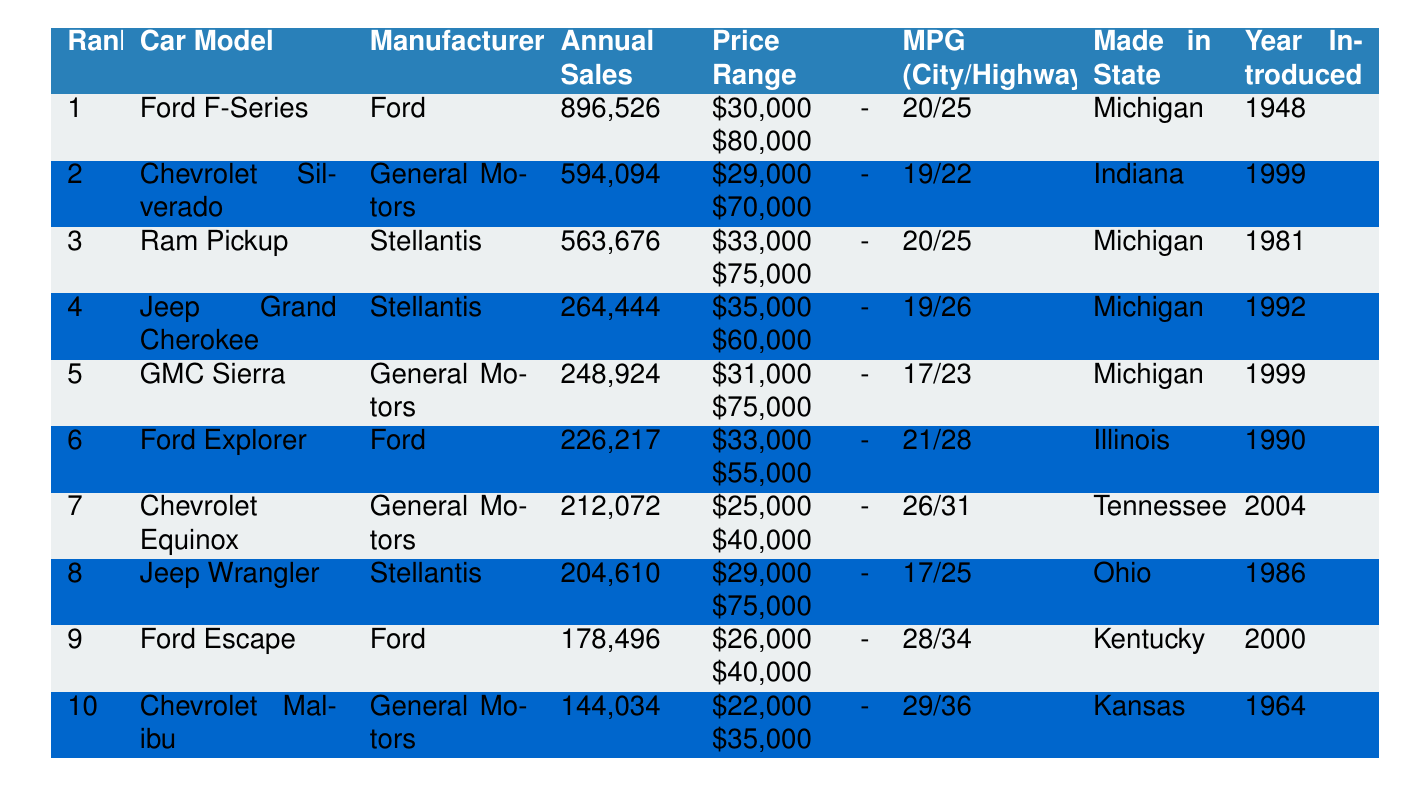What is the car model with the highest annual sales? Referring to the table, the car model listed at rank 1 is the Ford F-Series, which has the highest annual sales figure of 896,526.
Answer: Ford F-Series Which manufacturer produces the Jeep Wrangler? The table shows that the Jeep Wrangler is manufactured by Stellantis, as indicated in the "Manufacturer" column next to its name.
Answer: Stellantis What is the price range of the Chevrolet Silverado? By looking at the table, the price range for the Chevrolet Silverado is listed as $29,000 - $70,000.
Answer: $29,000 - $70,000 How many more annual sales does the Ford Explorer have than the Chevrolet Equinox? The annual sales for the Ford Explorer is 226,217, and for the Chevrolet Equinox, it is 212,072. The difference is 226,217 - 212,072 = 14,145.
Answer: 14,145 Which car model was introduced first, the Ford F-Series or the Chevrolet Malibu? The Ford F-Series was introduced in 1948 and the Chevrolet Malibu in 1964. Since 1948 is earlier than 1964, the Ford F-Series was introduced first.
Answer: Ford F-Series What are the MPG ratings for the Jeep Grand Cherokee? The table states that the Jeep Grand Cherokee has an MPG rating of 19 for city driving and 26 for highway driving.
Answer: 19/26 Which state produces the most car models listed in the top 10? By examining the "Made in State" column, we see Michigan produces 4 cars (Ford F-Series, Ram Pickup, Jeep Grand Cherokee, GMC Sierra), while other states produce fewer, indicating Michigan has the most.
Answer: Michigan What is the average annual sales for the top three car models? The annual sales for the top three models are 896,526 (Ford F-Series), 594,094 (Chevrolet Silverado), and 563,676 (Ram Pickup). The total sales is 896,526 + 594,094 + 563,676 = 2,054,296, and the average is 2,054,296 / 3 = 684,765.33.
Answer: 684,765 Does the Chevrolet Equinox have a better MPG rating than the GMC Sierra? The Chevrolet Equinox has an MPG of 26/31, while the GMC Sierra has 17/23. Since 26 (city) is greater than 17 and 31 (highway) is greater than 23, the Equinox does have a better rating.
Answer: Yes Which car model has the lowest annual sales, and how much is it? The table shows that the Chevrolet Malibu has the lowest annual sales at 144,034.
Answer: Chevrolet Malibu, 144,034 What percentage of the total annual sales from the top 10 cars does the Ford F-Series represent? The total sales for all top 10 cars is 896,526 + 594,094 + 563,676 + 264,444 + 248,924 + 226,217 + 212,072 + 204,610 + 178,496 + 144,034 = 3,074,099. The Ford F-Series sales are 896,526, so the percentage is (896,526 / 3,074,099) * 100 = 29.2%.
Answer: 29.2% 